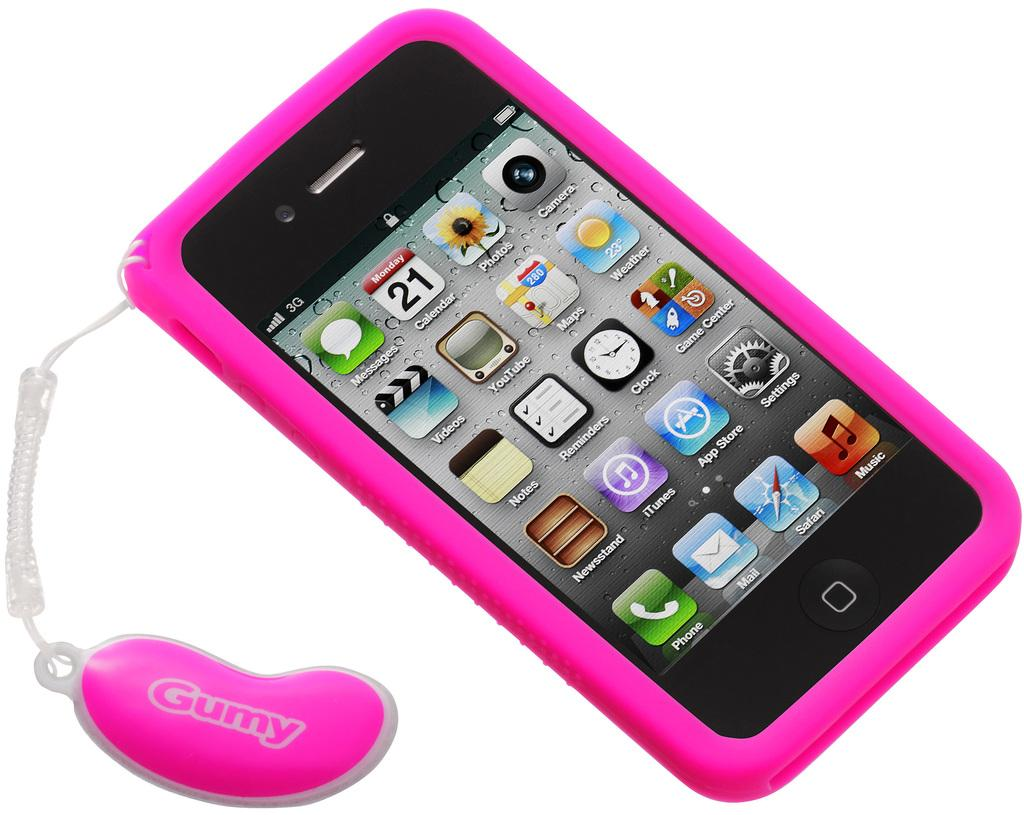<image>
Summarize the visual content of the image. A pink smartphone case with a tag coming off it that says Gumy. 